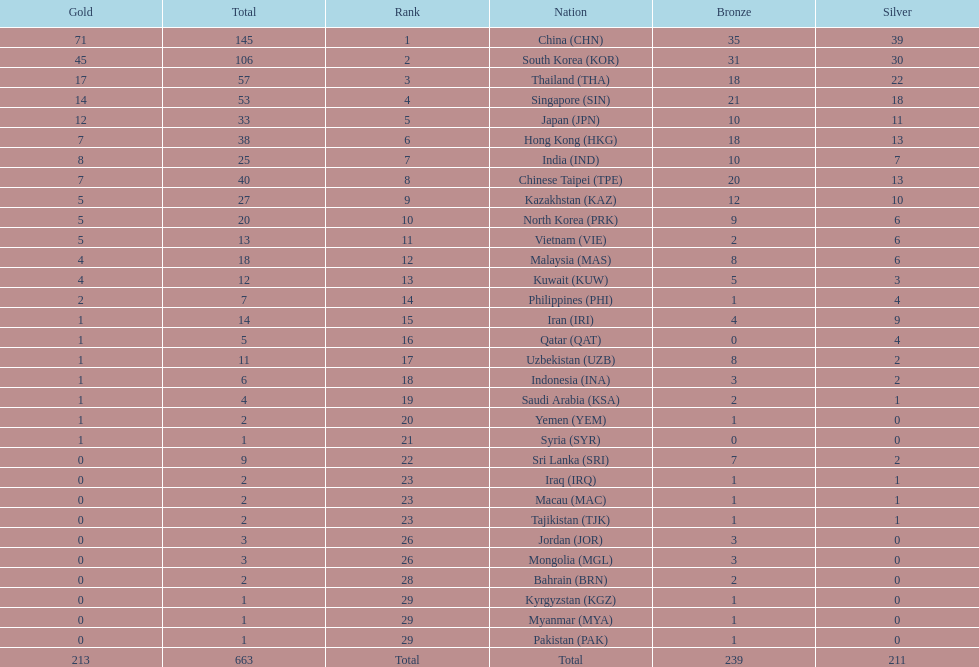What is the total number of medals that india won in the asian youth games? 25. 